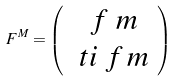<formula> <loc_0><loc_0><loc_500><loc_500>\ F ^ { M } = \left ( \begin{array} { c } \ f ^ { \ } m \\ \ t i \ f _ { \ } m \end{array} \right )</formula> 